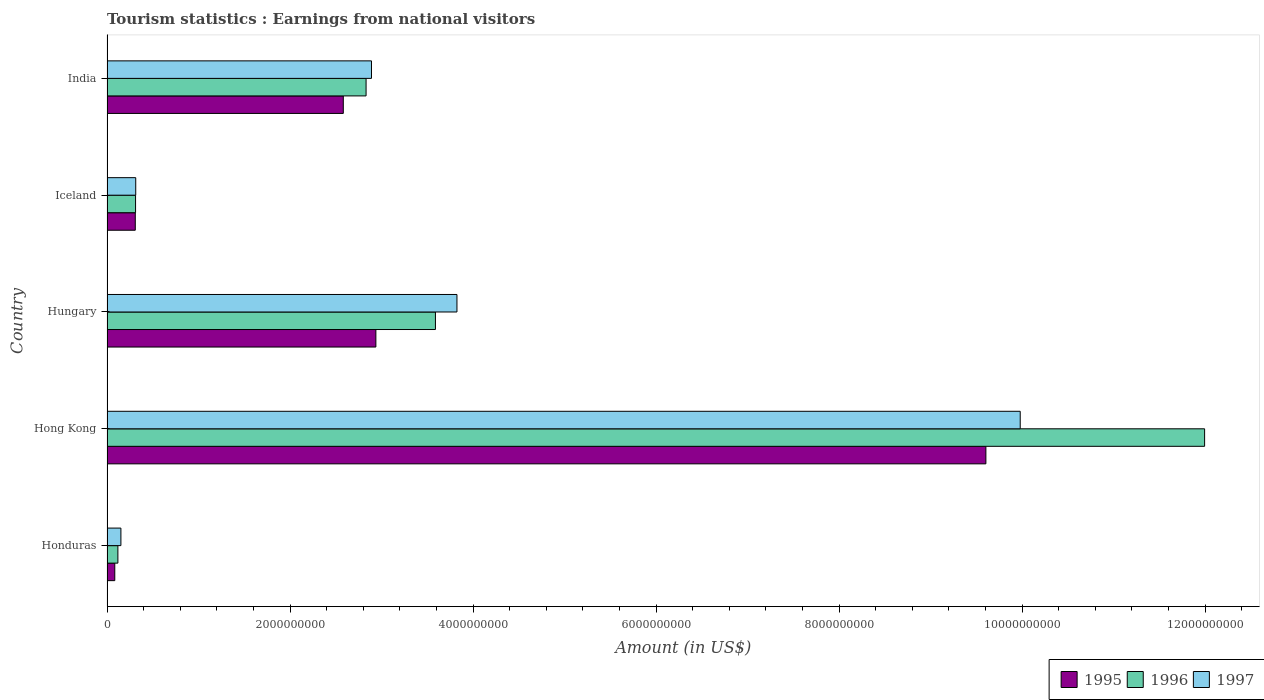How many groups of bars are there?
Your answer should be very brief. 5. Are the number of bars on each tick of the Y-axis equal?
Your response must be concise. Yes. What is the label of the 2nd group of bars from the top?
Provide a short and direct response. Iceland. In how many cases, is the number of bars for a given country not equal to the number of legend labels?
Your response must be concise. 0. What is the earnings from national visitors in 1995 in India?
Offer a very short reply. 2.58e+09. Across all countries, what is the maximum earnings from national visitors in 1997?
Provide a short and direct response. 9.98e+09. Across all countries, what is the minimum earnings from national visitors in 1995?
Give a very brief answer. 8.50e+07. In which country was the earnings from national visitors in 1997 maximum?
Provide a succinct answer. Hong Kong. In which country was the earnings from national visitors in 1997 minimum?
Offer a very short reply. Honduras. What is the total earnings from national visitors in 1996 in the graph?
Make the answer very short. 1.88e+1. What is the difference between the earnings from national visitors in 1997 in Hong Kong and that in Iceland?
Make the answer very short. 9.66e+09. What is the difference between the earnings from national visitors in 1996 in Honduras and the earnings from national visitors in 1997 in Hong Kong?
Provide a succinct answer. -9.86e+09. What is the average earnings from national visitors in 1995 per country?
Make the answer very short. 3.10e+09. In how many countries, is the earnings from national visitors in 1995 greater than 10400000000 US$?
Provide a short and direct response. 0. What is the ratio of the earnings from national visitors in 1996 in Hong Kong to that in India?
Give a very brief answer. 4.24. Is the difference between the earnings from national visitors in 1997 in Honduras and Iceland greater than the difference between the earnings from national visitors in 1996 in Honduras and Iceland?
Give a very brief answer. Yes. What is the difference between the highest and the second highest earnings from national visitors in 1997?
Your answer should be compact. 6.16e+09. What is the difference between the highest and the lowest earnings from national visitors in 1996?
Your answer should be compact. 1.19e+1. In how many countries, is the earnings from national visitors in 1995 greater than the average earnings from national visitors in 1995 taken over all countries?
Give a very brief answer. 1. Is the sum of the earnings from national visitors in 1997 in Hong Kong and India greater than the maximum earnings from national visitors in 1995 across all countries?
Keep it short and to the point. Yes. What does the 2nd bar from the bottom in Iceland represents?
Offer a very short reply. 1996. Are all the bars in the graph horizontal?
Ensure brevity in your answer.  Yes. How many countries are there in the graph?
Keep it short and to the point. 5. Does the graph contain any zero values?
Offer a terse response. No. Does the graph contain grids?
Your answer should be very brief. No. How are the legend labels stacked?
Your answer should be compact. Horizontal. What is the title of the graph?
Provide a short and direct response. Tourism statistics : Earnings from national visitors. Does "1971" appear as one of the legend labels in the graph?
Provide a short and direct response. No. What is the label or title of the X-axis?
Your answer should be very brief. Amount (in US$). What is the label or title of the Y-axis?
Your response must be concise. Country. What is the Amount (in US$) in 1995 in Honduras?
Keep it short and to the point. 8.50e+07. What is the Amount (in US$) in 1996 in Honduras?
Keep it short and to the point. 1.19e+08. What is the Amount (in US$) in 1997 in Honduras?
Offer a terse response. 1.52e+08. What is the Amount (in US$) in 1995 in Hong Kong?
Offer a very short reply. 9.60e+09. What is the Amount (in US$) in 1996 in Hong Kong?
Keep it short and to the point. 1.20e+1. What is the Amount (in US$) of 1997 in Hong Kong?
Offer a terse response. 9.98e+09. What is the Amount (in US$) of 1995 in Hungary?
Give a very brief answer. 2.94e+09. What is the Amount (in US$) of 1996 in Hungary?
Offer a very short reply. 3.59e+09. What is the Amount (in US$) of 1997 in Hungary?
Keep it short and to the point. 3.82e+09. What is the Amount (in US$) in 1995 in Iceland?
Provide a succinct answer. 3.09e+08. What is the Amount (in US$) in 1996 in Iceland?
Offer a terse response. 3.12e+08. What is the Amount (in US$) of 1997 in Iceland?
Your response must be concise. 3.14e+08. What is the Amount (in US$) in 1995 in India?
Give a very brief answer. 2.58e+09. What is the Amount (in US$) in 1996 in India?
Keep it short and to the point. 2.83e+09. What is the Amount (in US$) of 1997 in India?
Offer a very short reply. 2.89e+09. Across all countries, what is the maximum Amount (in US$) of 1995?
Provide a succinct answer. 9.60e+09. Across all countries, what is the maximum Amount (in US$) in 1996?
Your answer should be compact. 1.20e+1. Across all countries, what is the maximum Amount (in US$) of 1997?
Provide a short and direct response. 9.98e+09. Across all countries, what is the minimum Amount (in US$) in 1995?
Your response must be concise. 8.50e+07. Across all countries, what is the minimum Amount (in US$) in 1996?
Keep it short and to the point. 1.19e+08. Across all countries, what is the minimum Amount (in US$) of 1997?
Keep it short and to the point. 1.52e+08. What is the total Amount (in US$) in 1995 in the graph?
Make the answer very short. 1.55e+1. What is the total Amount (in US$) in 1996 in the graph?
Your answer should be compact. 1.88e+1. What is the total Amount (in US$) of 1997 in the graph?
Offer a very short reply. 1.72e+1. What is the difference between the Amount (in US$) of 1995 in Honduras and that in Hong Kong?
Make the answer very short. -9.52e+09. What is the difference between the Amount (in US$) of 1996 in Honduras and that in Hong Kong?
Your answer should be very brief. -1.19e+1. What is the difference between the Amount (in US$) in 1997 in Honduras and that in Hong Kong?
Give a very brief answer. -9.83e+09. What is the difference between the Amount (in US$) in 1995 in Honduras and that in Hungary?
Provide a short and direct response. -2.85e+09. What is the difference between the Amount (in US$) in 1996 in Honduras and that in Hungary?
Provide a succinct answer. -3.47e+09. What is the difference between the Amount (in US$) in 1997 in Honduras and that in Hungary?
Your answer should be very brief. -3.67e+09. What is the difference between the Amount (in US$) in 1995 in Honduras and that in Iceland?
Provide a short and direct response. -2.24e+08. What is the difference between the Amount (in US$) in 1996 in Honduras and that in Iceland?
Your answer should be very brief. -1.93e+08. What is the difference between the Amount (in US$) of 1997 in Honduras and that in Iceland?
Your answer should be very brief. -1.62e+08. What is the difference between the Amount (in US$) of 1995 in Honduras and that in India?
Make the answer very short. -2.50e+09. What is the difference between the Amount (in US$) in 1996 in Honduras and that in India?
Keep it short and to the point. -2.71e+09. What is the difference between the Amount (in US$) of 1997 in Honduras and that in India?
Offer a terse response. -2.74e+09. What is the difference between the Amount (in US$) of 1995 in Hong Kong and that in Hungary?
Your answer should be very brief. 6.67e+09. What is the difference between the Amount (in US$) of 1996 in Hong Kong and that in Hungary?
Provide a succinct answer. 8.40e+09. What is the difference between the Amount (in US$) of 1997 in Hong Kong and that in Hungary?
Make the answer very short. 6.16e+09. What is the difference between the Amount (in US$) in 1995 in Hong Kong and that in Iceland?
Keep it short and to the point. 9.30e+09. What is the difference between the Amount (in US$) of 1996 in Hong Kong and that in Iceland?
Ensure brevity in your answer.  1.17e+1. What is the difference between the Amount (in US$) of 1997 in Hong Kong and that in Iceland?
Your answer should be very brief. 9.66e+09. What is the difference between the Amount (in US$) of 1995 in Hong Kong and that in India?
Ensure brevity in your answer.  7.02e+09. What is the difference between the Amount (in US$) of 1996 in Hong Kong and that in India?
Provide a succinct answer. 9.16e+09. What is the difference between the Amount (in US$) in 1997 in Hong Kong and that in India?
Your response must be concise. 7.09e+09. What is the difference between the Amount (in US$) in 1995 in Hungary and that in Iceland?
Your answer should be compact. 2.63e+09. What is the difference between the Amount (in US$) in 1996 in Hungary and that in Iceland?
Provide a succinct answer. 3.28e+09. What is the difference between the Amount (in US$) in 1997 in Hungary and that in Iceland?
Keep it short and to the point. 3.51e+09. What is the difference between the Amount (in US$) of 1995 in Hungary and that in India?
Your answer should be very brief. 3.56e+08. What is the difference between the Amount (in US$) of 1996 in Hungary and that in India?
Make the answer very short. 7.58e+08. What is the difference between the Amount (in US$) in 1997 in Hungary and that in India?
Your response must be concise. 9.34e+08. What is the difference between the Amount (in US$) of 1995 in Iceland and that in India?
Your answer should be compact. -2.27e+09. What is the difference between the Amount (in US$) in 1996 in Iceland and that in India?
Provide a succinct answer. -2.52e+09. What is the difference between the Amount (in US$) of 1997 in Iceland and that in India?
Give a very brief answer. -2.58e+09. What is the difference between the Amount (in US$) in 1995 in Honduras and the Amount (in US$) in 1996 in Hong Kong?
Your answer should be compact. -1.19e+1. What is the difference between the Amount (in US$) of 1995 in Honduras and the Amount (in US$) of 1997 in Hong Kong?
Keep it short and to the point. -9.89e+09. What is the difference between the Amount (in US$) of 1996 in Honduras and the Amount (in US$) of 1997 in Hong Kong?
Ensure brevity in your answer.  -9.86e+09. What is the difference between the Amount (in US$) in 1995 in Honduras and the Amount (in US$) in 1996 in Hungary?
Your response must be concise. -3.50e+09. What is the difference between the Amount (in US$) in 1995 in Honduras and the Amount (in US$) in 1997 in Hungary?
Make the answer very short. -3.74e+09. What is the difference between the Amount (in US$) in 1996 in Honduras and the Amount (in US$) in 1997 in Hungary?
Provide a short and direct response. -3.70e+09. What is the difference between the Amount (in US$) of 1995 in Honduras and the Amount (in US$) of 1996 in Iceland?
Your answer should be compact. -2.27e+08. What is the difference between the Amount (in US$) in 1995 in Honduras and the Amount (in US$) in 1997 in Iceland?
Your response must be concise. -2.29e+08. What is the difference between the Amount (in US$) of 1996 in Honduras and the Amount (in US$) of 1997 in Iceland?
Ensure brevity in your answer.  -1.95e+08. What is the difference between the Amount (in US$) of 1995 in Honduras and the Amount (in US$) of 1996 in India?
Your response must be concise. -2.75e+09. What is the difference between the Amount (in US$) of 1995 in Honduras and the Amount (in US$) of 1997 in India?
Make the answer very short. -2.80e+09. What is the difference between the Amount (in US$) of 1996 in Honduras and the Amount (in US$) of 1997 in India?
Keep it short and to the point. -2.77e+09. What is the difference between the Amount (in US$) in 1995 in Hong Kong and the Amount (in US$) in 1996 in Hungary?
Offer a terse response. 6.02e+09. What is the difference between the Amount (in US$) in 1995 in Hong Kong and the Amount (in US$) in 1997 in Hungary?
Your answer should be compact. 5.78e+09. What is the difference between the Amount (in US$) in 1996 in Hong Kong and the Amount (in US$) in 1997 in Hungary?
Make the answer very short. 8.17e+09. What is the difference between the Amount (in US$) in 1995 in Hong Kong and the Amount (in US$) in 1996 in Iceland?
Offer a very short reply. 9.29e+09. What is the difference between the Amount (in US$) in 1995 in Hong Kong and the Amount (in US$) in 1997 in Iceland?
Your answer should be very brief. 9.29e+09. What is the difference between the Amount (in US$) of 1996 in Hong Kong and the Amount (in US$) of 1997 in Iceland?
Provide a short and direct response. 1.17e+1. What is the difference between the Amount (in US$) of 1995 in Hong Kong and the Amount (in US$) of 1996 in India?
Provide a short and direct response. 6.77e+09. What is the difference between the Amount (in US$) in 1995 in Hong Kong and the Amount (in US$) in 1997 in India?
Make the answer very short. 6.71e+09. What is the difference between the Amount (in US$) in 1996 in Hong Kong and the Amount (in US$) in 1997 in India?
Make the answer very short. 9.10e+09. What is the difference between the Amount (in US$) in 1995 in Hungary and the Amount (in US$) in 1996 in Iceland?
Your answer should be very brief. 2.63e+09. What is the difference between the Amount (in US$) of 1995 in Hungary and the Amount (in US$) of 1997 in Iceland?
Your response must be concise. 2.62e+09. What is the difference between the Amount (in US$) of 1996 in Hungary and the Amount (in US$) of 1997 in Iceland?
Your answer should be compact. 3.28e+09. What is the difference between the Amount (in US$) of 1995 in Hungary and the Amount (in US$) of 1996 in India?
Give a very brief answer. 1.07e+08. What is the difference between the Amount (in US$) of 1995 in Hungary and the Amount (in US$) of 1997 in India?
Ensure brevity in your answer.  4.80e+07. What is the difference between the Amount (in US$) of 1996 in Hungary and the Amount (in US$) of 1997 in India?
Your answer should be very brief. 6.99e+08. What is the difference between the Amount (in US$) in 1995 in Iceland and the Amount (in US$) in 1996 in India?
Make the answer very short. -2.52e+09. What is the difference between the Amount (in US$) in 1995 in Iceland and the Amount (in US$) in 1997 in India?
Ensure brevity in your answer.  -2.58e+09. What is the difference between the Amount (in US$) of 1996 in Iceland and the Amount (in US$) of 1997 in India?
Make the answer very short. -2.58e+09. What is the average Amount (in US$) in 1995 per country?
Your answer should be very brief. 3.10e+09. What is the average Amount (in US$) in 1996 per country?
Offer a very short reply. 3.77e+09. What is the average Amount (in US$) of 1997 per country?
Your answer should be compact. 3.43e+09. What is the difference between the Amount (in US$) of 1995 and Amount (in US$) of 1996 in Honduras?
Give a very brief answer. -3.40e+07. What is the difference between the Amount (in US$) in 1995 and Amount (in US$) in 1997 in Honduras?
Give a very brief answer. -6.70e+07. What is the difference between the Amount (in US$) of 1996 and Amount (in US$) of 1997 in Honduras?
Make the answer very short. -3.30e+07. What is the difference between the Amount (in US$) of 1995 and Amount (in US$) of 1996 in Hong Kong?
Your response must be concise. -2.39e+09. What is the difference between the Amount (in US$) of 1995 and Amount (in US$) of 1997 in Hong Kong?
Give a very brief answer. -3.75e+08. What is the difference between the Amount (in US$) of 1996 and Amount (in US$) of 1997 in Hong Kong?
Make the answer very short. 2.02e+09. What is the difference between the Amount (in US$) of 1995 and Amount (in US$) of 1996 in Hungary?
Offer a terse response. -6.51e+08. What is the difference between the Amount (in US$) in 1995 and Amount (in US$) in 1997 in Hungary?
Give a very brief answer. -8.86e+08. What is the difference between the Amount (in US$) of 1996 and Amount (in US$) of 1997 in Hungary?
Make the answer very short. -2.35e+08. What is the difference between the Amount (in US$) of 1995 and Amount (in US$) of 1997 in Iceland?
Ensure brevity in your answer.  -5.00e+06. What is the difference between the Amount (in US$) in 1995 and Amount (in US$) in 1996 in India?
Make the answer very short. -2.49e+08. What is the difference between the Amount (in US$) in 1995 and Amount (in US$) in 1997 in India?
Ensure brevity in your answer.  -3.08e+08. What is the difference between the Amount (in US$) in 1996 and Amount (in US$) in 1997 in India?
Your answer should be compact. -5.90e+07. What is the ratio of the Amount (in US$) of 1995 in Honduras to that in Hong Kong?
Your response must be concise. 0.01. What is the ratio of the Amount (in US$) in 1996 in Honduras to that in Hong Kong?
Ensure brevity in your answer.  0.01. What is the ratio of the Amount (in US$) in 1997 in Honduras to that in Hong Kong?
Offer a terse response. 0.02. What is the ratio of the Amount (in US$) in 1995 in Honduras to that in Hungary?
Your answer should be very brief. 0.03. What is the ratio of the Amount (in US$) in 1996 in Honduras to that in Hungary?
Make the answer very short. 0.03. What is the ratio of the Amount (in US$) of 1997 in Honduras to that in Hungary?
Give a very brief answer. 0.04. What is the ratio of the Amount (in US$) of 1995 in Honduras to that in Iceland?
Keep it short and to the point. 0.28. What is the ratio of the Amount (in US$) of 1996 in Honduras to that in Iceland?
Offer a very short reply. 0.38. What is the ratio of the Amount (in US$) in 1997 in Honduras to that in Iceland?
Provide a short and direct response. 0.48. What is the ratio of the Amount (in US$) of 1995 in Honduras to that in India?
Provide a short and direct response. 0.03. What is the ratio of the Amount (in US$) of 1996 in Honduras to that in India?
Keep it short and to the point. 0.04. What is the ratio of the Amount (in US$) of 1997 in Honduras to that in India?
Ensure brevity in your answer.  0.05. What is the ratio of the Amount (in US$) in 1995 in Hong Kong to that in Hungary?
Your answer should be very brief. 3.27. What is the ratio of the Amount (in US$) in 1996 in Hong Kong to that in Hungary?
Provide a short and direct response. 3.34. What is the ratio of the Amount (in US$) in 1997 in Hong Kong to that in Hungary?
Keep it short and to the point. 2.61. What is the ratio of the Amount (in US$) in 1995 in Hong Kong to that in Iceland?
Your answer should be compact. 31.08. What is the ratio of the Amount (in US$) of 1996 in Hong Kong to that in Iceland?
Give a very brief answer. 38.44. What is the ratio of the Amount (in US$) in 1997 in Hong Kong to that in Iceland?
Make the answer very short. 31.78. What is the ratio of the Amount (in US$) of 1995 in Hong Kong to that in India?
Make the answer very short. 3.72. What is the ratio of the Amount (in US$) of 1996 in Hong Kong to that in India?
Ensure brevity in your answer.  4.24. What is the ratio of the Amount (in US$) of 1997 in Hong Kong to that in India?
Your answer should be compact. 3.45. What is the ratio of the Amount (in US$) in 1995 in Hungary to that in Iceland?
Your answer should be very brief. 9.51. What is the ratio of the Amount (in US$) in 1996 in Hungary to that in Iceland?
Make the answer very short. 11.5. What is the ratio of the Amount (in US$) of 1997 in Hungary to that in Iceland?
Give a very brief answer. 12.18. What is the ratio of the Amount (in US$) in 1995 in Hungary to that in India?
Provide a succinct answer. 1.14. What is the ratio of the Amount (in US$) of 1996 in Hungary to that in India?
Ensure brevity in your answer.  1.27. What is the ratio of the Amount (in US$) of 1997 in Hungary to that in India?
Give a very brief answer. 1.32. What is the ratio of the Amount (in US$) in 1995 in Iceland to that in India?
Your answer should be very brief. 0.12. What is the ratio of the Amount (in US$) of 1996 in Iceland to that in India?
Provide a succinct answer. 0.11. What is the ratio of the Amount (in US$) in 1997 in Iceland to that in India?
Your answer should be compact. 0.11. What is the difference between the highest and the second highest Amount (in US$) in 1995?
Provide a short and direct response. 6.67e+09. What is the difference between the highest and the second highest Amount (in US$) in 1996?
Your answer should be very brief. 8.40e+09. What is the difference between the highest and the second highest Amount (in US$) in 1997?
Ensure brevity in your answer.  6.16e+09. What is the difference between the highest and the lowest Amount (in US$) of 1995?
Ensure brevity in your answer.  9.52e+09. What is the difference between the highest and the lowest Amount (in US$) of 1996?
Keep it short and to the point. 1.19e+1. What is the difference between the highest and the lowest Amount (in US$) of 1997?
Keep it short and to the point. 9.83e+09. 